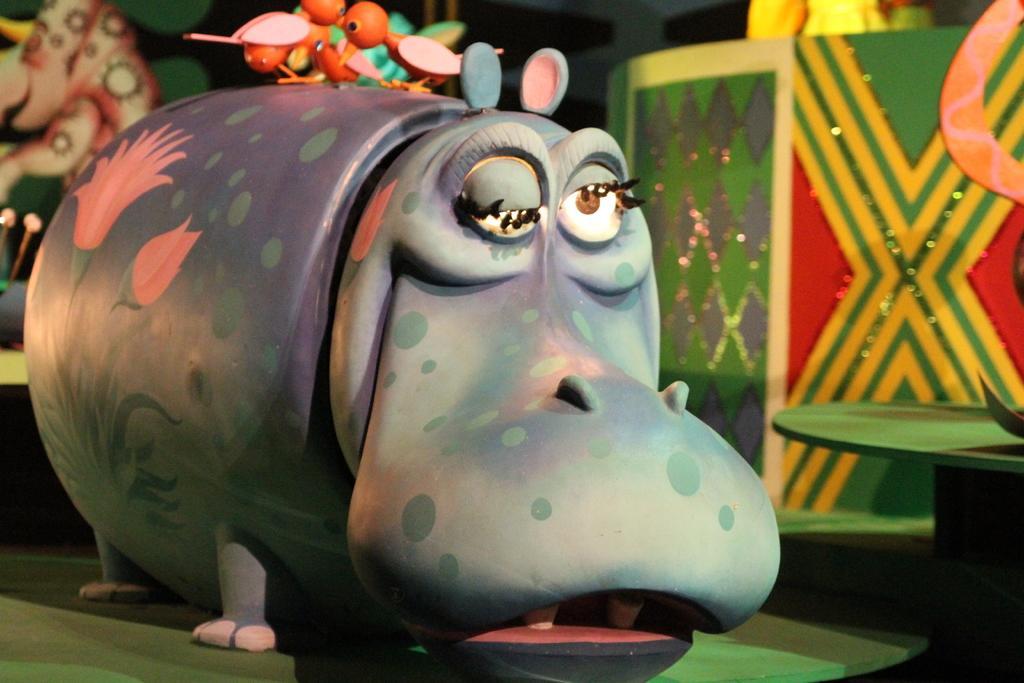In one or two sentences, can you explain what this image depicts? In the center of the image we can see a toy of hippopotamus. At the top of the image some toys are there. In the background of the image a decor is there. At the bottom of the image ground is there. On the right side of the image a table is there. 